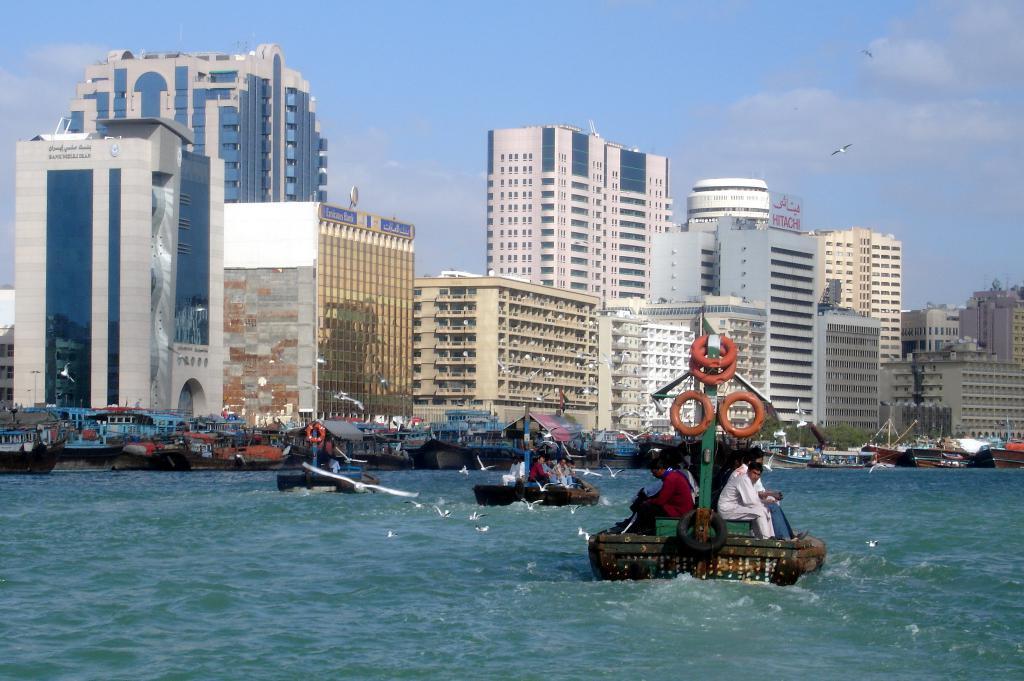Describe this image in one or two sentences. In the image we can see there are boats docked on the lake and there are people sitting in the boats. There are birds standing on the lake and there are other boats docked on the lake. Behind there are buildings and there is a bird flying in the sky. The sky is clear. 